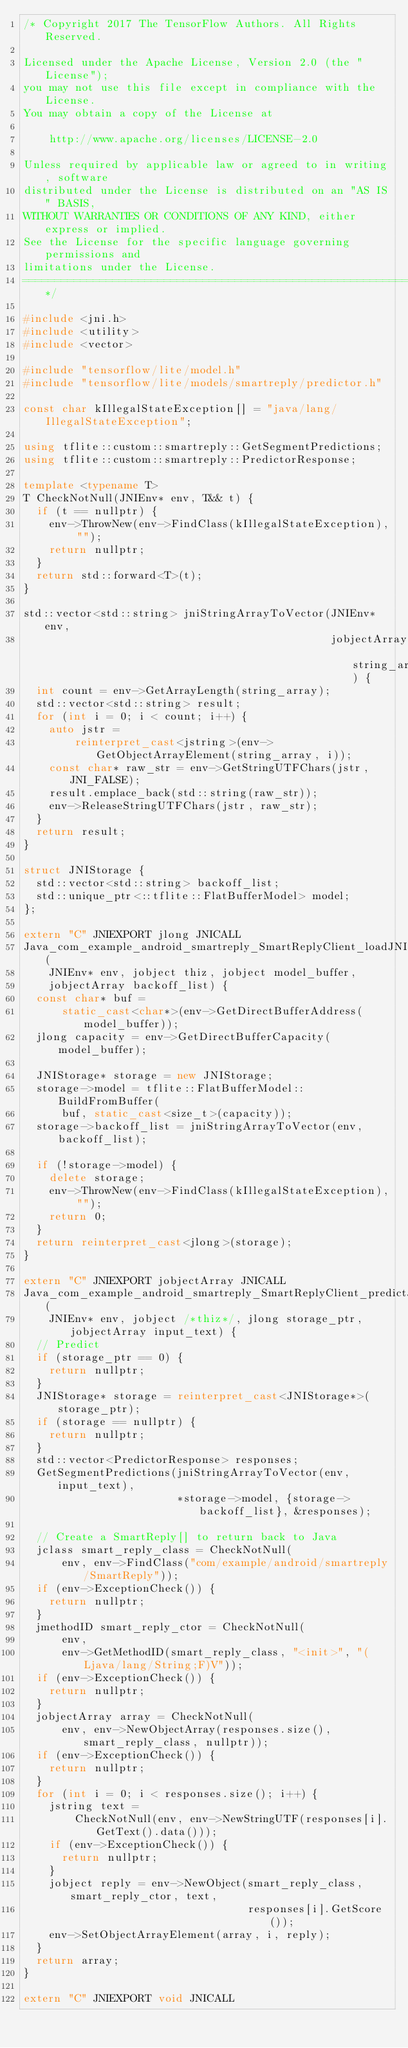Convert code to text. <code><loc_0><loc_0><loc_500><loc_500><_C++_>/* Copyright 2017 The TensorFlow Authors. All Rights Reserved.

Licensed under the Apache License, Version 2.0 (the "License");
you may not use this file except in compliance with the License.
You may obtain a copy of the License at

    http://www.apache.org/licenses/LICENSE-2.0

Unless required by applicable law or agreed to in writing, software
distributed under the License is distributed on an "AS IS" BASIS,
WITHOUT WARRANTIES OR CONDITIONS OF ANY KIND, either express or implied.
See the License for the specific language governing permissions and
limitations under the License.
==============================================================================*/

#include <jni.h>
#include <utility>
#include <vector>

#include "tensorflow/lite/model.h"
#include "tensorflow/lite/models/smartreply/predictor.h"

const char kIllegalStateException[] = "java/lang/IllegalStateException";

using tflite::custom::smartreply::GetSegmentPredictions;
using tflite::custom::smartreply::PredictorResponse;

template <typename T>
T CheckNotNull(JNIEnv* env, T&& t) {
  if (t == nullptr) {
    env->ThrowNew(env->FindClass(kIllegalStateException), "");
    return nullptr;
  }
  return std::forward<T>(t);
}

std::vector<std::string> jniStringArrayToVector(JNIEnv* env,
                                                jobjectArray string_array) {
  int count = env->GetArrayLength(string_array);
  std::vector<std::string> result;
  for (int i = 0; i < count; i++) {
    auto jstr =
        reinterpret_cast<jstring>(env->GetObjectArrayElement(string_array, i));
    const char* raw_str = env->GetStringUTFChars(jstr, JNI_FALSE);
    result.emplace_back(std::string(raw_str));
    env->ReleaseStringUTFChars(jstr, raw_str);
  }
  return result;
}

struct JNIStorage {
  std::vector<std::string> backoff_list;
  std::unique_ptr<::tflite::FlatBufferModel> model;
};

extern "C" JNIEXPORT jlong JNICALL
Java_com_example_android_smartreply_SmartReplyClient_loadJNI(
    JNIEnv* env, jobject thiz, jobject model_buffer,
    jobjectArray backoff_list) {
  const char* buf =
      static_cast<char*>(env->GetDirectBufferAddress(model_buffer));
  jlong capacity = env->GetDirectBufferCapacity(model_buffer);

  JNIStorage* storage = new JNIStorage;
  storage->model = tflite::FlatBufferModel::BuildFromBuffer(
      buf, static_cast<size_t>(capacity));
  storage->backoff_list = jniStringArrayToVector(env, backoff_list);

  if (!storage->model) {
    delete storage;
    env->ThrowNew(env->FindClass(kIllegalStateException), "");
    return 0;
  }
  return reinterpret_cast<jlong>(storage);
}

extern "C" JNIEXPORT jobjectArray JNICALL
Java_com_example_android_smartreply_SmartReplyClient_predictJNI(
    JNIEnv* env, jobject /*thiz*/, jlong storage_ptr, jobjectArray input_text) {
  // Predict
  if (storage_ptr == 0) {
    return nullptr;
  }
  JNIStorage* storage = reinterpret_cast<JNIStorage*>(storage_ptr);
  if (storage == nullptr) {
    return nullptr;
  }
  std::vector<PredictorResponse> responses;
  GetSegmentPredictions(jniStringArrayToVector(env, input_text),
                        *storage->model, {storage->backoff_list}, &responses);

  // Create a SmartReply[] to return back to Java
  jclass smart_reply_class = CheckNotNull(
      env, env->FindClass("com/example/android/smartreply/SmartReply"));
  if (env->ExceptionCheck()) {
    return nullptr;
  }
  jmethodID smart_reply_ctor = CheckNotNull(
      env,
      env->GetMethodID(smart_reply_class, "<init>", "(Ljava/lang/String;F)V"));
  if (env->ExceptionCheck()) {
    return nullptr;
  }
  jobjectArray array = CheckNotNull(
      env, env->NewObjectArray(responses.size(), smart_reply_class, nullptr));
  if (env->ExceptionCheck()) {
    return nullptr;
  }
  for (int i = 0; i < responses.size(); i++) {
    jstring text =
        CheckNotNull(env, env->NewStringUTF(responses[i].GetText().data()));
    if (env->ExceptionCheck()) {
      return nullptr;
    }
    jobject reply = env->NewObject(smart_reply_class, smart_reply_ctor, text,
                                   responses[i].GetScore());
    env->SetObjectArrayElement(array, i, reply);
  }
  return array;
}

extern "C" JNIEXPORT void JNICALL</code> 